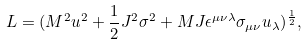Convert formula to latex. <formula><loc_0><loc_0><loc_500><loc_500>L = ( M ^ { 2 } u ^ { 2 } + \frac { 1 } { 2 } J ^ { 2 } \sigma ^ { 2 } + M J \epsilon ^ { \mu \nu \lambda } \sigma _ { \mu \nu } u _ { \lambda } ) ^ { \frac { 1 } { 2 } } ,</formula> 